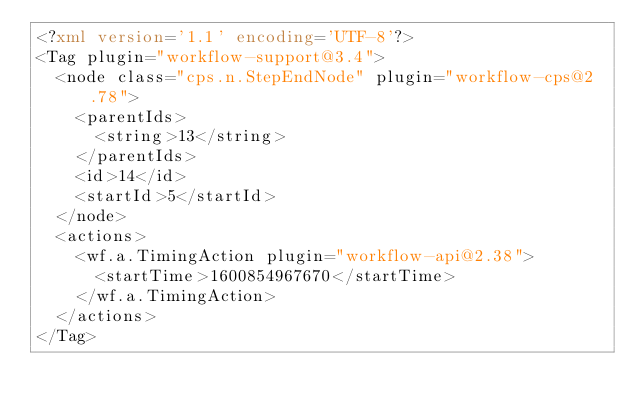Convert code to text. <code><loc_0><loc_0><loc_500><loc_500><_XML_><?xml version='1.1' encoding='UTF-8'?>
<Tag plugin="workflow-support@3.4">
  <node class="cps.n.StepEndNode" plugin="workflow-cps@2.78">
    <parentIds>
      <string>13</string>
    </parentIds>
    <id>14</id>
    <startId>5</startId>
  </node>
  <actions>
    <wf.a.TimingAction plugin="workflow-api@2.38">
      <startTime>1600854967670</startTime>
    </wf.a.TimingAction>
  </actions>
</Tag></code> 